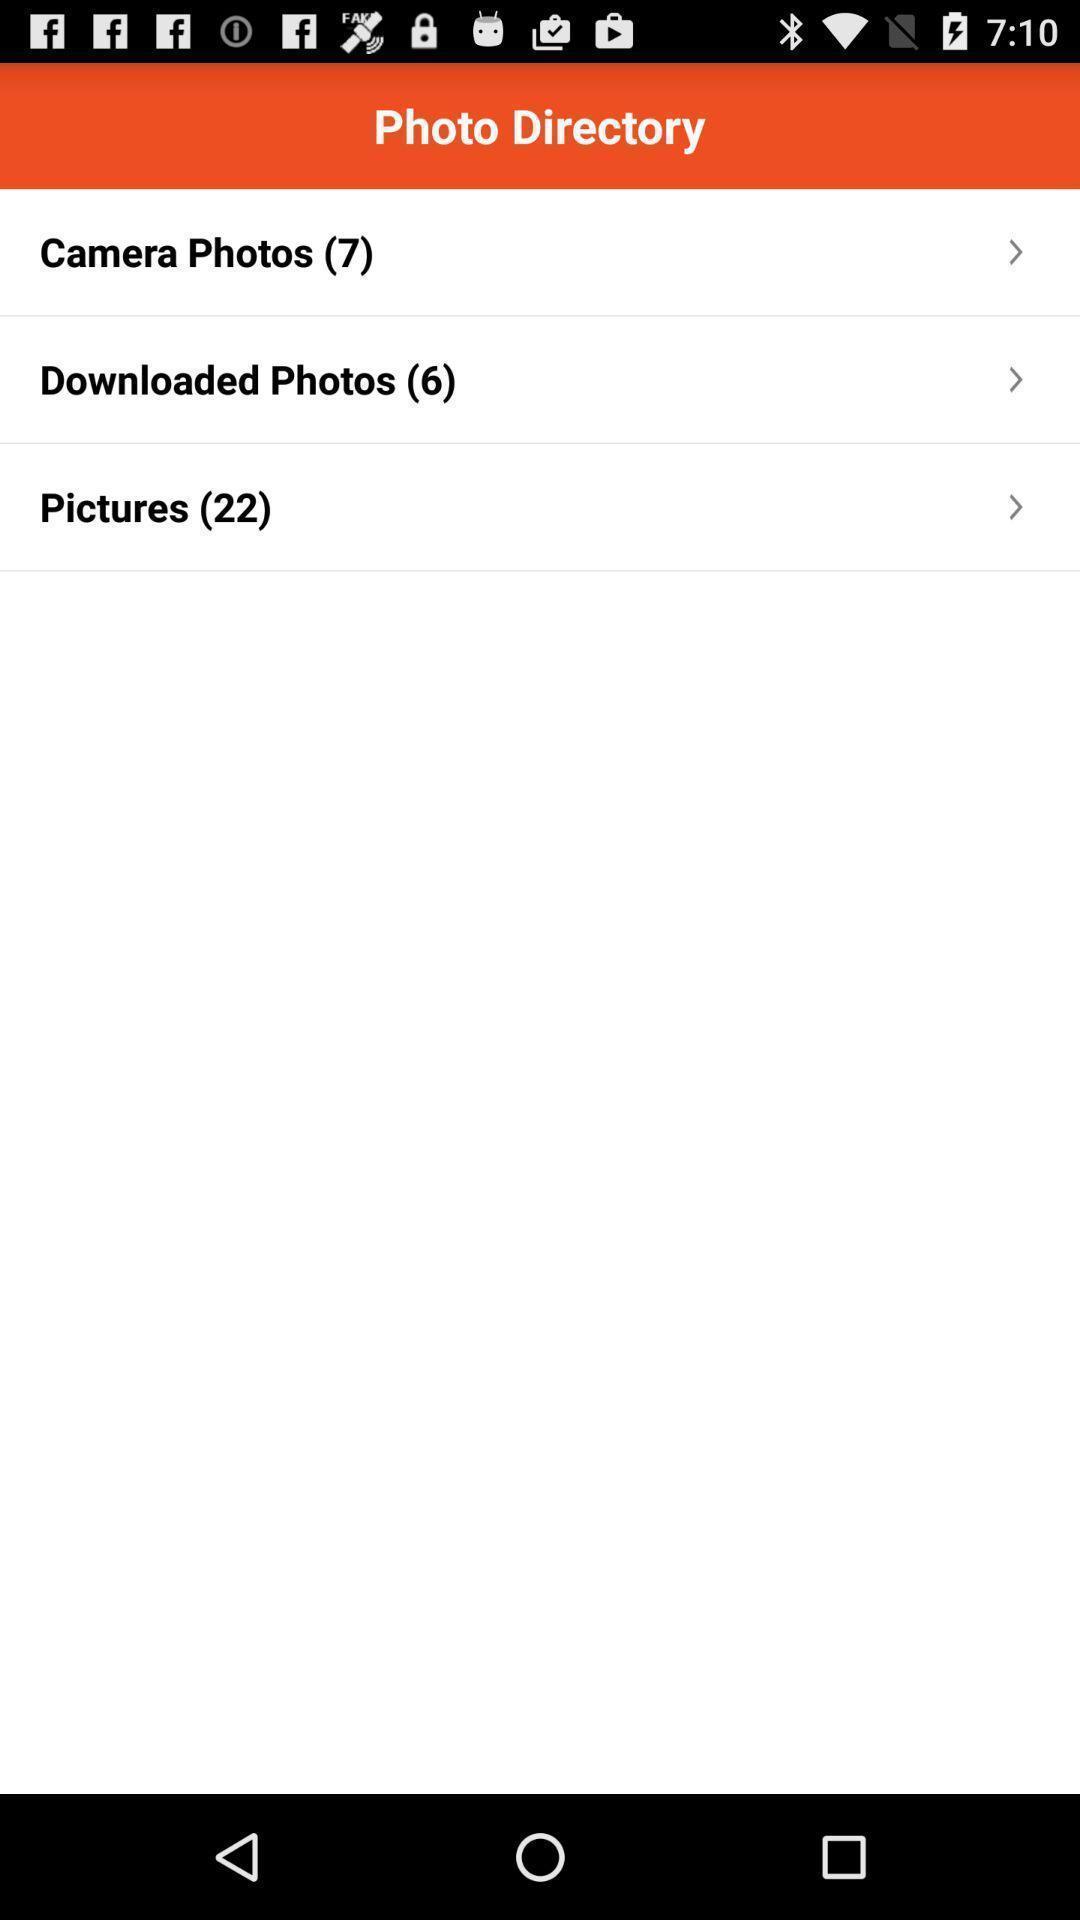Explain what's happening in this screen capture. Screen displaying the list of folders in photos page. 